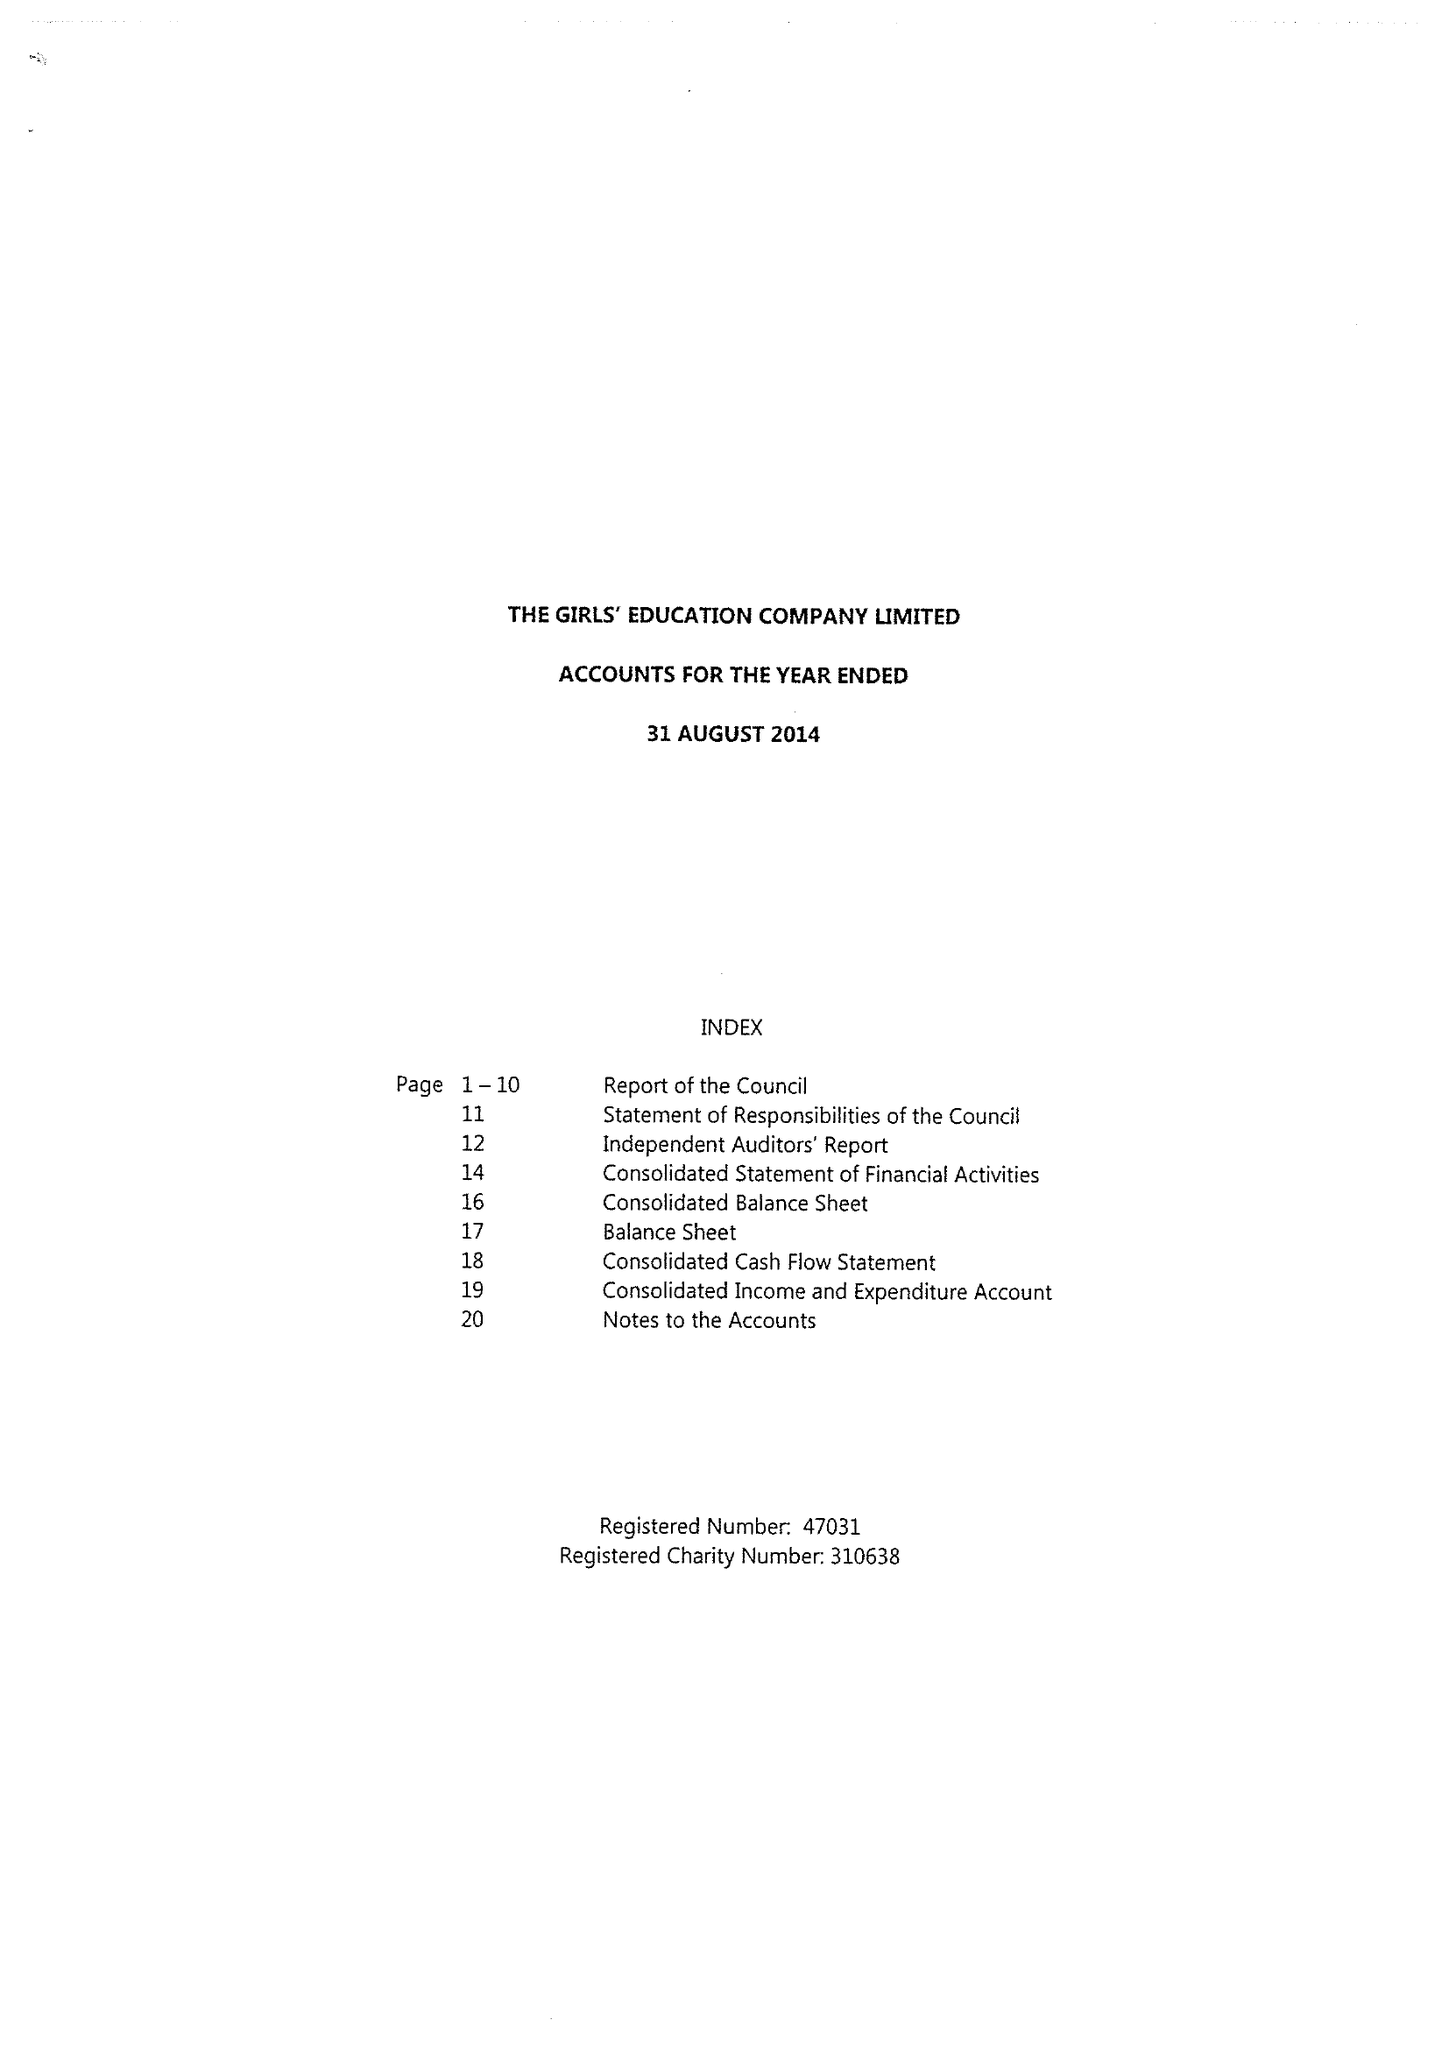What is the value for the address__postcode?
Answer the question using a single word or phrase. HP11 1PE 